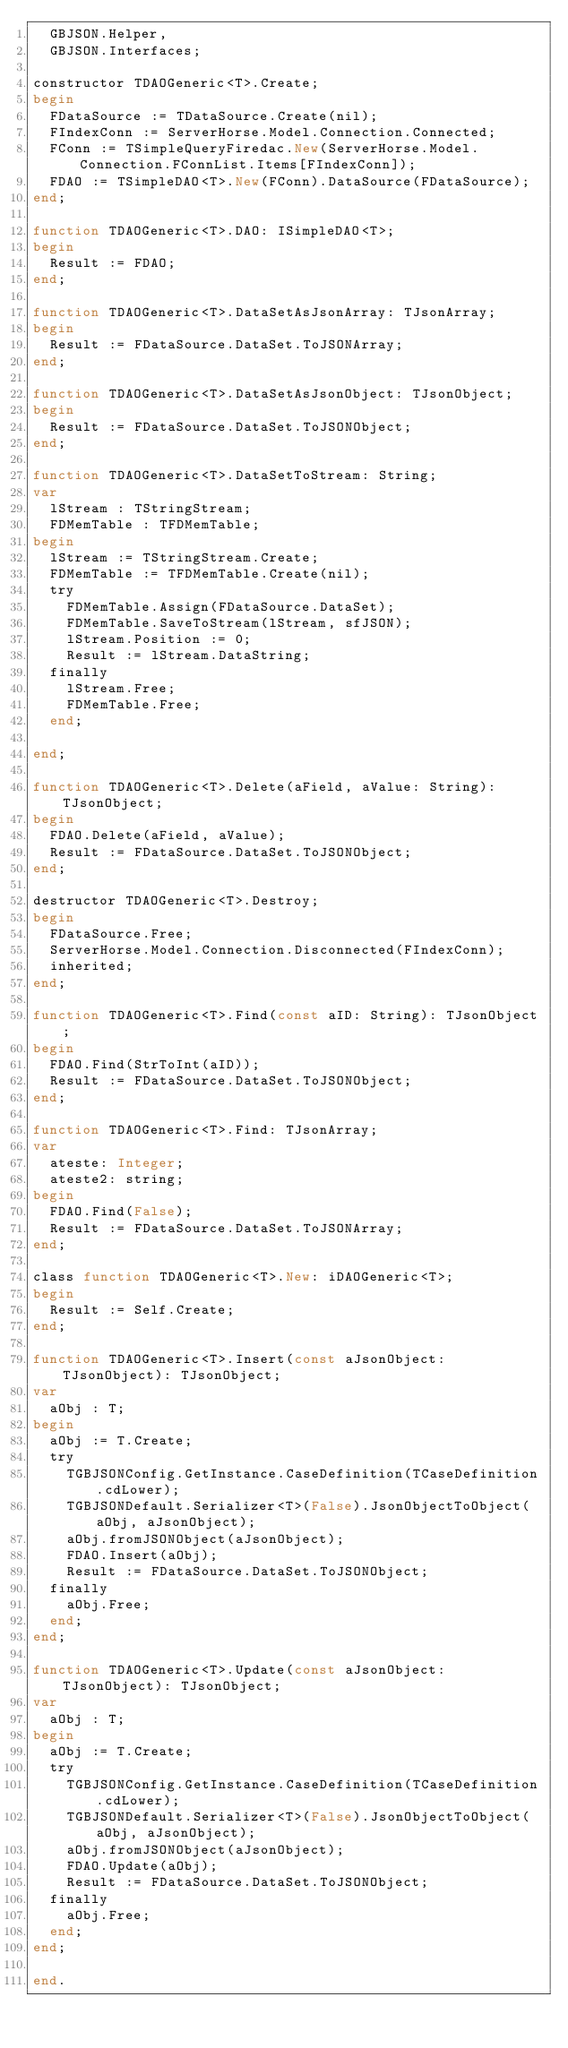<code> <loc_0><loc_0><loc_500><loc_500><_Pascal_>  GBJSON.Helper,
  GBJSON.Interfaces;

constructor TDAOGeneric<T>.Create;
begin
  FDataSource := TDataSource.Create(nil);
  FIndexConn := ServerHorse.Model.Connection.Connected;
  FConn := TSimpleQueryFiredac.New(ServerHorse.Model.Connection.FConnList.Items[FIndexConn]);
  FDAO := TSimpleDAO<T>.New(FConn).DataSource(FDataSource);
end;

function TDAOGeneric<T>.DAO: ISimpleDAO<T>;
begin
  Result := FDAO;
end;

function TDAOGeneric<T>.DataSetAsJsonArray: TJsonArray;
begin
  Result := FDataSource.DataSet.ToJSONArray;
end;

function TDAOGeneric<T>.DataSetAsJsonObject: TJsonObject;
begin
  Result := FDataSource.DataSet.ToJSONObject;
end;

function TDAOGeneric<T>.DataSetToStream: String;
var
  lStream : TStringStream;
  FDMemTable : TFDMemTable;
begin
  lStream := TStringStream.Create;
  FDMemTable := TFDMemTable.Create(nil);
  try
    FDMemTable.Assign(FDataSource.DataSet);
    FDMemTable.SaveToStream(lStream, sfJSON);
    lStream.Position := 0;
    Result := lStream.DataString;
  finally
    lStream.Free;
    FDMemTable.Free;
  end;

end;

function TDAOGeneric<T>.Delete(aField, aValue: String): TJsonObject;
begin
  FDAO.Delete(aField, aValue);
  Result := FDataSource.DataSet.ToJSONObject;
end;

destructor TDAOGeneric<T>.Destroy;
begin
  FDataSource.Free;
  ServerHorse.Model.Connection.Disconnected(FIndexConn);
  inherited;
end;

function TDAOGeneric<T>.Find(const aID: String): TJsonObject;
begin
  FDAO.Find(StrToInt(aID));
  Result := FDataSource.DataSet.ToJSONObject;
end;

function TDAOGeneric<T>.Find: TJsonArray;
var
  ateste: Integer;
  ateste2: string;
begin
  FDAO.Find(False);
  Result := FDataSource.DataSet.ToJSONArray;
end;

class function TDAOGeneric<T>.New: iDAOGeneric<T>;
begin
  Result := Self.Create;
end;

function TDAOGeneric<T>.Insert(const aJsonObject: TJsonObject): TJsonObject;
var
  aObj : T;
begin
  aObj := T.Create;
  try
    TGBJSONConfig.GetInstance.CaseDefinition(TCaseDefinition.cdLower);
    TGBJSONDefault.Serializer<T>(False).JsonObjectToObject(aObj, aJsonObject);
    aObj.fromJSONObject(aJsonObject);
    FDAO.Insert(aObj);
    Result := FDataSource.DataSet.ToJSONObject;
  finally
    aObj.Free;
  end;
end;

function TDAOGeneric<T>.Update(const aJsonObject: TJsonObject): TJsonObject;
var
  aObj : T;
begin
  aObj := T.Create;
  try
    TGBJSONConfig.GetInstance.CaseDefinition(TCaseDefinition.cdLower);
    TGBJSONDefault.Serializer<T>(False).JsonObjectToObject(aObj, aJsonObject);
    aObj.fromJSONObject(aJsonObject);
    FDAO.Update(aObj);
    Result := FDataSource.DataSet.ToJSONObject;
  finally
    aObj.Free;
  end;
end;

end.
</code> 